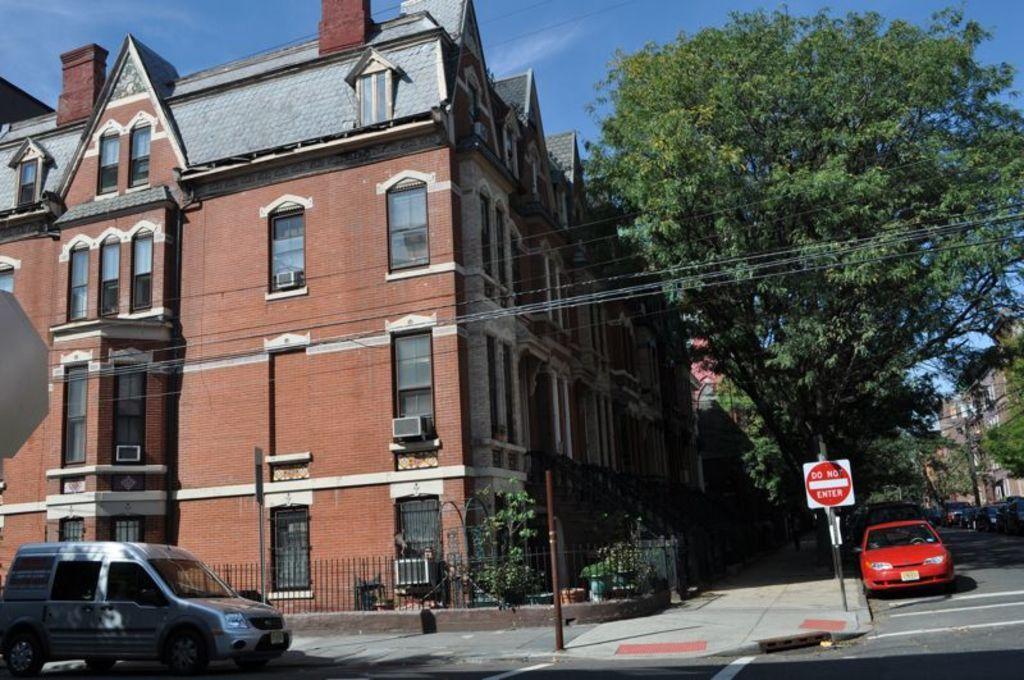In one or two sentences, can you explain what this image depicts? In this image there is a building, in front of the building there is a railing and few vehicles are on the road, there are few sign boards and poles. In the background there are trees, buildings and the sky. 